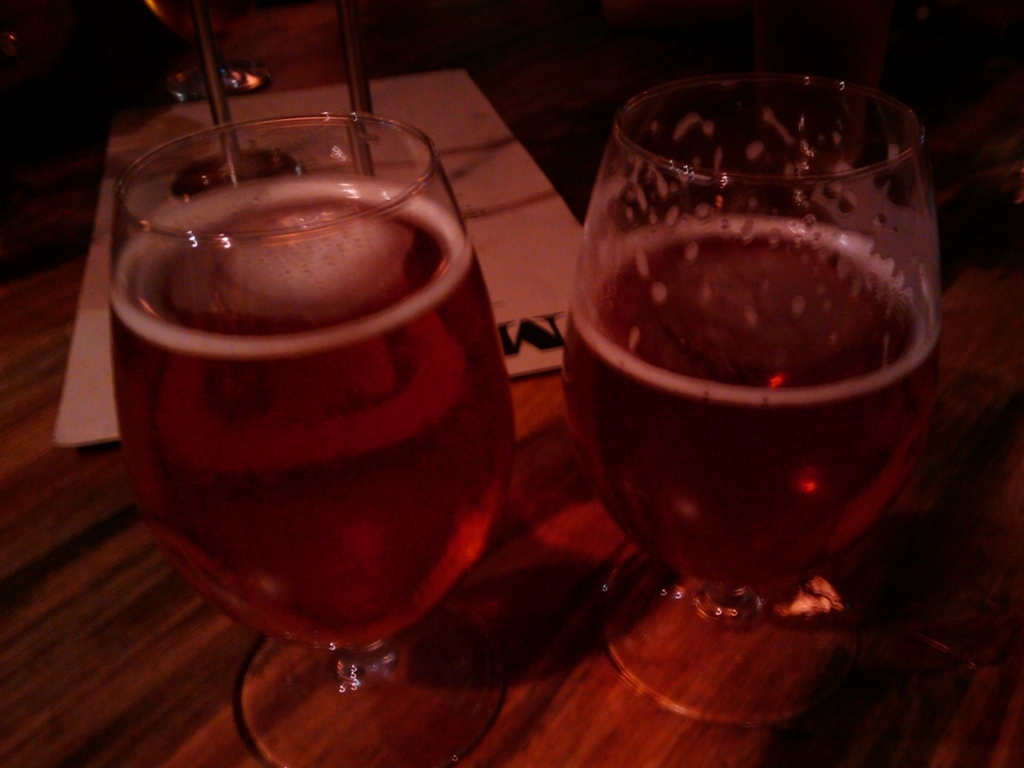Can you guess at what time of day this photo was taken? It is challenging to ascertain the exact time of day from the image's content alone, but considering the low lighting, it could imply an evening or night setting, which is a common time to visit a bar and enjoy a drink. 